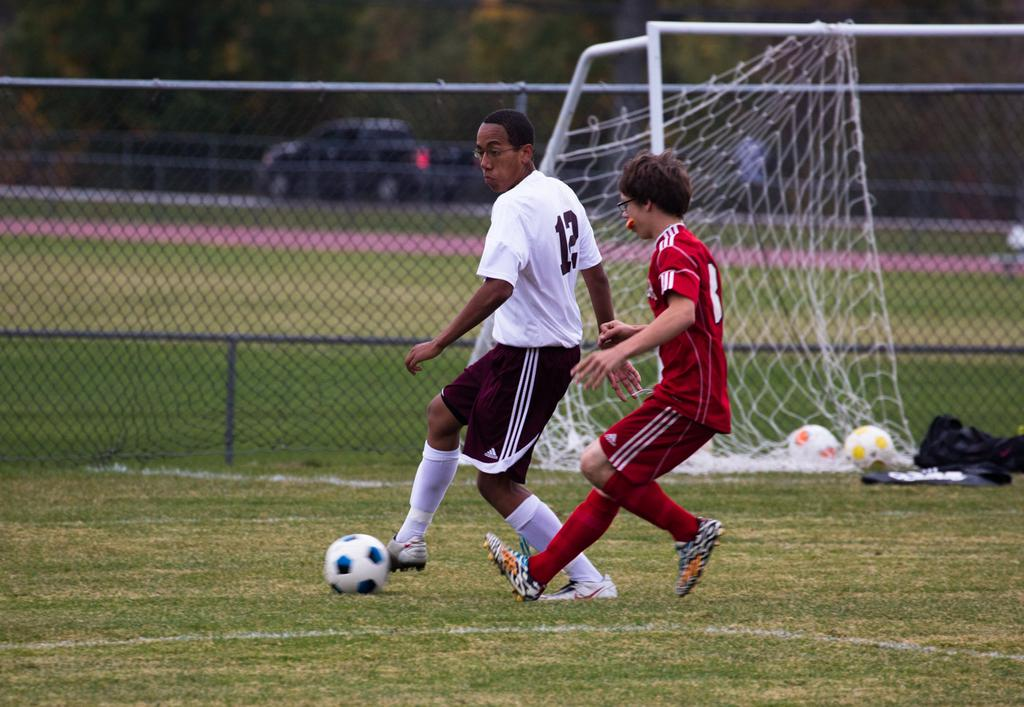Provide a one-sentence caption for the provided image. A player numbered 12 is attempting to steal the soccer ball from a man in a red jersey. 